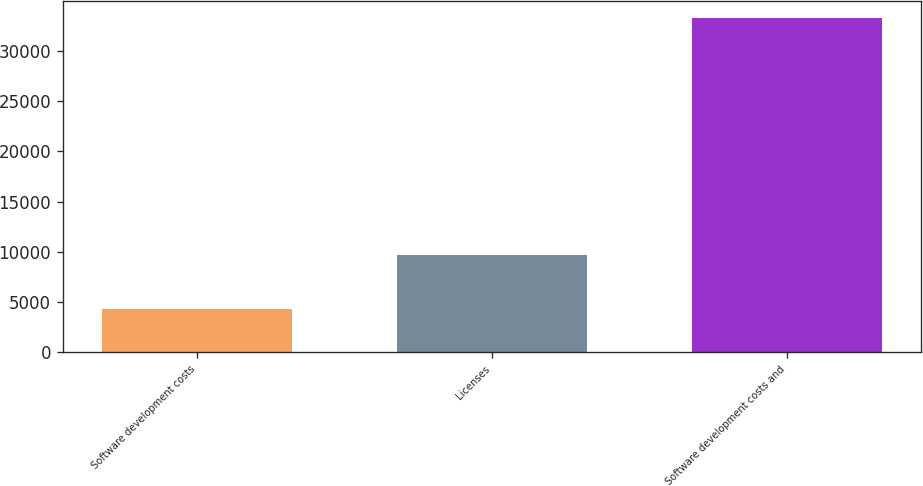<chart> <loc_0><loc_0><loc_500><loc_500><bar_chart><fcel>Software development costs<fcel>Licenses<fcel>Software development costs and<nl><fcel>4275<fcel>9671<fcel>33284<nl></chart> 